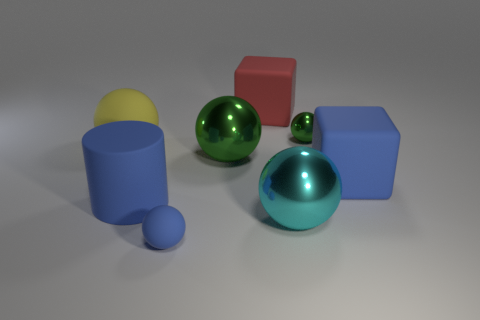Can you describe the arrangement of the shapes in the image? Certainly! The image shows a variety of three-dimensional shapes arranged on a flat surface. There's a blue cylinder on the left with a small blue sphere in front of it. Two metallic spheres, one green and one teal, are near the center, with the green one being closer to the foreground. To the right, there are two blocks: one red cube and a blue rectangular prism. The smaller green sphere appears to be nestled between the green metallic sphere and the red cube. 